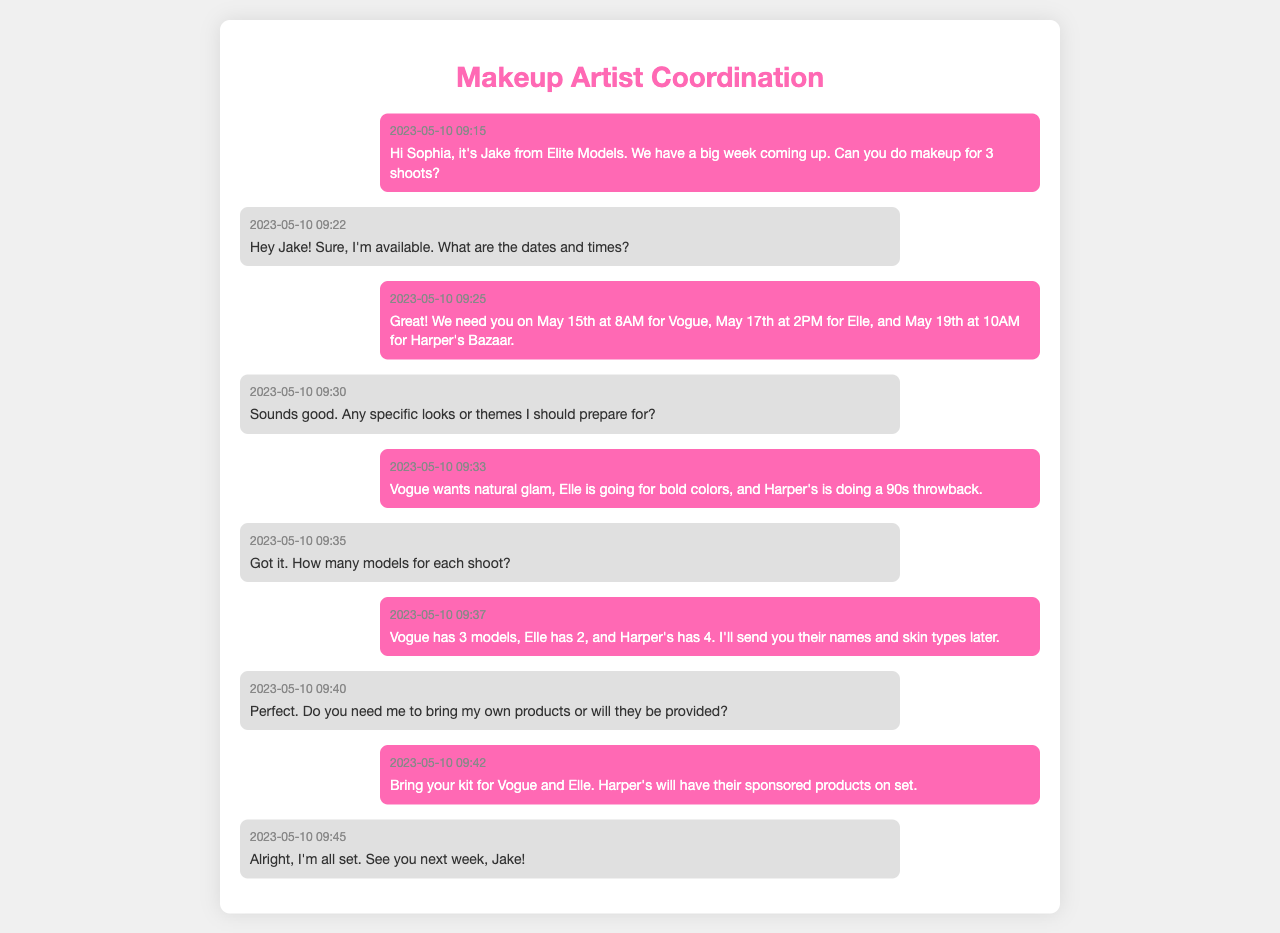What date is the Vogue photoshoot scheduled for? The document specifies the date for the Vogue photoshoot as May 15th.
Answer: May 15th How many models will be at the Harper's Bazaar shoot? The document mentions that Harper's has 4 models.
Answer: 4 What theme should the makeup artist prepare for the Elle photoshoot? The document states that Elle is going for bold colors.
Answer: Bold colors What time is the shoot for Elle scheduled? The document indicates that the Elle photoshoot is at 2 PM on May 17th.
Answer: 2 PM What specific glam style does Vogue want? The document specifies that Vogue wants natural glam.
Answer: Natural glam How many photoshoots are being coordinated? From the document, it is clear that there are 3 photoshoots being coordinated.
Answer: 3 What will Harper's Bazaar provide for the makeup artist? According to the document, Harper's will have their sponsored products on set.
Answer: Sponsored products What time is the Harper's shoot? The document indicates the Harper's Bazaar shoot is at 10 AM.
Answer: 10 AM Does the makeup artist need to bring her own products for the Harper's shoot? The document states that Harper's will provide products; thus, she does not need to bring her own.
Answer: No 